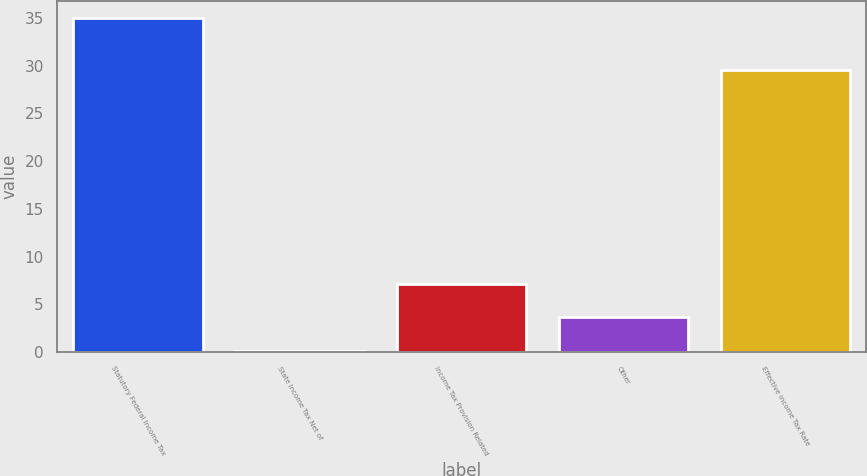<chart> <loc_0><loc_0><loc_500><loc_500><bar_chart><fcel>Statutory Federal Income Tax<fcel>State Income Tax Net of<fcel>Income Tax Provision Related<fcel>Other<fcel>Effective Income Tax Rate<nl><fcel>35<fcel>0.15<fcel>7.12<fcel>3.64<fcel>29.59<nl></chart> 